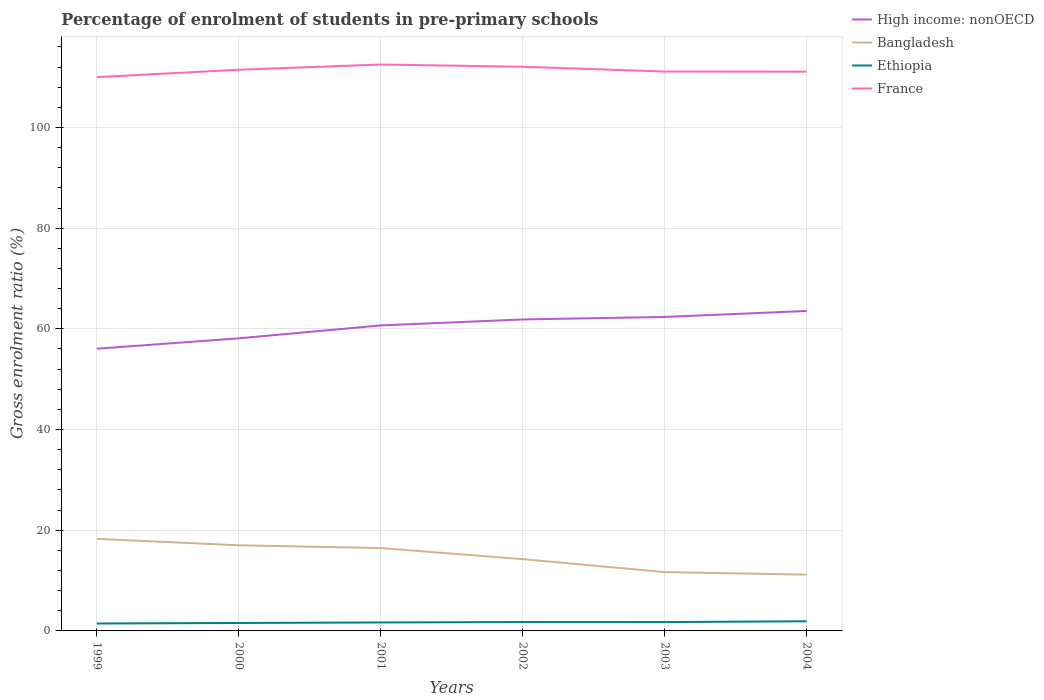Across all years, what is the maximum percentage of students enrolled in pre-primary schools in High income: nonOECD?
Ensure brevity in your answer.  56.05. In which year was the percentage of students enrolled in pre-primary schools in France maximum?
Provide a succinct answer. 1999. What is the total percentage of students enrolled in pre-primary schools in France in the graph?
Offer a very short reply. 0.36. What is the difference between the highest and the second highest percentage of students enrolled in pre-primary schools in High income: nonOECD?
Provide a short and direct response. 7.5. How many lines are there?
Your response must be concise. 4. How many years are there in the graph?
Your answer should be very brief. 6. Are the values on the major ticks of Y-axis written in scientific E-notation?
Your response must be concise. No. Does the graph contain any zero values?
Make the answer very short. No. Does the graph contain grids?
Make the answer very short. Yes. Where does the legend appear in the graph?
Offer a terse response. Top right. How many legend labels are there?
Offer a very short reply. 4. How are the legend labels stacked?
Offer a very short reply. Vertical. What is the title of the graph?
Offer a very short reply. Percentage of enrolment of students in pre-primary schools. What is the label or title of the X-axis?
Offer a terse response. Years. What is the Gross enrolment ratio (%) in High income: nonOECD in 1999?
Ensure brevity in your answer.  56.05. What is the Gross enrolment ratio (%) in Bangladesh in 1999?
Give a very brief answer. 18.29. What is the Gross enrolment ratio (%) of Ethiopia in 1999?
Your answer should be very brief. 1.47. What is the Gross enrolment ratio (%) in France in 1999?
Ensure brevity in your answer.  110. What is the Gross enrolment ratio (%) of High income: nonOECD in 2000?
Offer a terse response. 58.12. What is the Gross enrolment ratio (%) of Bangladesh in 2000?
Offer a very short reply. 17.01. What is the Gross enrolment ratio (%) in Ethiopia in 2000?
Give a very brief answer. 1.58. What is the Gross enrolment ratio (%) in France in 2000?
Your answer should be very brief. 111.47. What is the Gross enrolment ratio (%) in High income: nonOECD in 2001?
Ensure brevity in your answer.  60.68. What is the Gross enrolment ratio (%) in Bangladesh in 2001?
Make the answer very short. 16.46. What is the Gross enrolment ratio (%) of Ethiopia in 2001?
Give a very brief answer. 1.68. What is the Gross enrolment ratio (%) in France in 2001?
Offer a very short reply. 112.5. What is the Gross enrolment ratio (%) in High income: nonOECD in 2002?
Your answer should be very brief. 61.87. What is the Gross enrolment ratio (%) of Bangladesh in 2002?
Your answer should be compact. 14.25. What is the Gross enrolment ratio (%) in Ethiopia in 2002?
Ensure brevity in your answer.  1.76. What is the Gross enrolment ratio (%) in France in 2002?
Offer a terse response. 112.06. What is the Gross enrolment ratio (%) in High income: nonOECD in 2003?
Keep it short and to the point. 62.36. What is the Gross enrolment ratio (%) in Bangladesh in 2003?
Your answer should be compact. 11.68. What is the Gross enrolment ratio (%) in Ethiopia in 2003?
Provide a short and direct response. 1.76. What is the Gross enrolment ratio (%) of France in 2003?
Your response must be concise. 111.1. What is the Gross enrolment ratio (%) of High income: nonOECD in 2004?
Give a very brief answer. 63.55. What is the Gross enrolment ratio (%) in Bangladesh in 2004?
Provide a succinct answer. 11.18. What is the Gross enrolment ratio (%) in Ethiopia in 2004?
Your response must be concise. 1.92. What is the Gross enrolment ratio (%) of France in 2004?
Ensure brevity in your answer.  111.08. Across all years, what is the maximum Gross enrolment ratio (%) in High income: nonOECD?
Your answer should be compact. 63.55. Across all years, what is the maximum Gross enrolment ratio (%) of Bangladesh?
Provide a succinct answer. 18.29. Across all years, what is the maximum Gross enrolment ratio (%) of Ethiopia?
Offer a terse response. 1.92. Across all years, what is the maximum Gross enrolment ratio (%) in France?
Keep it short and to the point. 112.5. Across all years, what is the minimum Gross enrolment ratio (%) in High income: nonOECD?
Give a very brief answer. 56.05. Across all years, what is the minimum Gross enrolment ratio (%) of Bangladesh?
Give a very brief answer. 11.18. Across all years, what is the minimum Gross enrolment ratio (%) of Ethiopia?
Give a very brief answer. 1.47. Across all years, what is the minimum Gross enrolment ratio (%) in France?
Provide a short and direct response. 110. What is the total Gross enrolment ratio (%) in High income: nonOECD in the graph?
Provide a succinct answer. 362.62. What is the total Gross enrolment ratio (%) in Bangladesh in the graph?
Your response must be concise. 88.87. What is the total Gross enrolment ratio (%) in Ethiopia in the graph?
Your response must be concise. 10.17. What is the total Gross enrolment ratio (%) of France in the graph?
Your response must be concise. 668.2. What is the difference between the Gross enrolment ratio (%) in High income: nonOECD in 1999 and that in 2000?
Your answer should be compact. -2.07. What is the difference between the Gross enrolment ratio (%) in Bangladesh in 1999 and that in 2000?
Provide a short and direct response. 1.28. What is the difference between the Gross enrolment ratio (%) of Ethiopia in 1999 and that in 2000?
Provide a short and direct response. -0.1. What is the difference between the Gross enrolment ratio (%) in France in 1999 and that in 2000?
Make the answer very short. -1.47. What is the difference between the Gross enrolment ratio (%) in High income: nonOECD in 1999 and that in 2001?
Your response must be concise. -4.63. What is the difference between the Gross enrolment ratio (%) in Bangladesh in 1999 and that in 2001?
Your response must be concise. 1.83. What is the difference between the Gross enrolment ratio (%) of Ethiopia in 1999 and that in 2001?
Ensure brevity in your answer.  -0.21. What is the difference between the Gross enrolment ratio (%) in France in 1999 and that in 2001?
Your response must be concise. -2.5. What is the difference between the Gross enrolment ratio (%) of High income: nonOECD in 1999 and that in 2002?
Make the answer very short. -5.81. What is the difference between the Gross enrolment ratio (%) in Bangladesh in 1999 and that in 2002?
Ensure brevity in your answer.  4.03. What is the difference between the Gross enrolment ratio (%) of Ethiopia in 1999 and that in 2002?
Make the answer very short. -0.29. What is the difference between the Gross enrolment ratio (%) in France in 1999 and that in 2002?
Offer a terse response. -2.06. What is the difference between the Gross enrolment ratio (%) of High income: nonOECD in 1999 and that in 2003?
Ensure brevity in your answer.  -6.31. What is the difference between the Gross enrolment ratio (%) of Bangladesh in 1999 and that in 2003?
Make the answer very short. 6.6. What is the difference between the Gross enrolment ratio (%) of Ethiopia in 1999 and that in 2003?
Your response must be concise. -0.28. What is the difference between the Gross enrolment ratio (%) in France in 1999 and that in 2003?
Ensure brevity in your answer.  -1.11. What is the difference between the Gross enrolment ratio (%) in High income: nonOECD in 1999 and that in 2004?
Your response must be concise. -7.5. What is the difference between the Gross enrolment ratio (%) of Bangladesh in 1999 and that in 2004?
Give a very brief answer. 7.11. What is the difference between the Gross enrolment ratio (%) in Ethiopia in 1999 and that in 2004?
Give a very brief answer. -0.44. What is the difference between the Gross enrolment ratio (%) of France in 1999 and that in 2004?
Your answer should be compact. -1.08. What is the difference between the Gross enrolment ratio (%) in High income: nonOECD in 2000 and that in 2001?
Ensure brevity in your answer.  -2.56. What is the difference between the Gross enrolment ratio (%) in Bangladesh in 2000 and that in 2001?
Offer a very short reply. 0.55. What is the difference between the Gross enrolment ratio (%) in Ethiopia in 2000 and that in 2001?
Your answer should be very brief. -0.1. What is the difference between the Gross enrolment ratio (%) in France in 2000 and that in 2001?
Your answer should be compact. -1.03. What is the difference between the Gross enrolment ratio (%) in High income: nonOECD in 2000 and that in 2002?
Provide a succinct answer. -3.75. What is the difference between the Gross enrolment ratio (%) in Bangladesh in 2000 and that in 2002?
Your response must be concise. 2.75. What is the difference between the Gross enrolment ratio (%) of Ethiopia in 2000 and that in 2002?
Offer a very short reply. -0.19. What is the difference between the Gross enrolment ratio (%) in France in 2000 and that in 2002?
Ensure brevity in your answer.  -0.59. What is the difference between the Gross enrolment ratio (%) of High income: nonOECD in 2000 and that in 2003?
Ensure brevity in your answer.  -4.24. What is the difference between the Gross enrolment ratio (%) in Bangladesh in 2000 and that in 2003?
Provide a succinct answer. 5.32. What is the difference between the Gross enrolment ratio (%) in Ethiopia in 2000 and that in 2003?
Provide a succinct answer. -0.18. What is the difference between the Gross enrolment ratio (%) of France in 2000 and that in 2003?
Offer a very short reply. 0.36. What is the difference between the Gross enrolment ratio (%) in High income: nonOECD in 2000 and that in 2004?
Offer a very short reply. -5.43. What is the difference between the Gross enrolment ratio (%) in Bangladesh in 2000 and that in 2004?
Provide a short and direct response. 5.83. What is the difference between the Gross enrolment ratio (%) in Ethiopia in 2000 and that in 2004?
Provide a succinct answer. -0.34. What is the difference between the Gross enrolment ratio (%) of France in 2000 and that in 2004?
Your response must be concise. 0.39. What is the difference between the Gross enrolment ratio (%) in High income: nonOECD in 2001 and that in 2002?
Offer a very short reply. -1.19. What is the difference between the Gross enrolment ratio (%) in Bangladesh in 2001 and that in 2002?
Offer a terse response. 2.2. What is the difference between the Gross enrolment ratio (%) of Ethiopia in 2001 and that in 2002?
Give a very brief answer. -0.08. What is the difference between the Gross enrolment ratio (%) of France in 2001 and that in 2002?
Ensure brevity in your answer.  0.44. What is the difference between the Gross enrolment ratio (%) in High income: nonOECD in 2001 and that in 2003?
Your response must be concise. -1.68. What is the difference between the Gross enrolment ratio (%) in Bangladesh in 2001 and that in 2003?
Provide a succinct answer. 4.77. What is the difference between the Gross enrolment ratio (%) of Ethiopia in 2001 and that in 2003?
Offer a very short reply. -0.07. What is the difference between the Gross enrolment ratio (%) of France in 2001 and that in 2003?
Ensure brevity in your answer.  1.39. What is the difference between the Gross enrolment ratio (%) in High income: nonOECD in 2001 and that in 2004?
Give a very brief answer. -2.87. What is the difference between the Gross enrolment ratio (%) in Bangladesh in 2001 and that in 2004?
Provide a succinct answer. 5.28. What is the difference between the Gross enrolment ratio (%) in Ethiopia in 2001 and that in 2004?
Ensure brevity in your answer.  -0.23. What is the difference between the Gross enrolment ratio (%) in France in 2001 and that in 2004?
Your answer should be compact. 1.42. What is the difference between the Gross enrolment ratio (%) in High income: nonOECD in 2002 and that in 2003?
Keep it short and to the point. -0.49. What is the difference between the Gross enrolment ratio (%) of Bangladesh in 2002 and that in 2003?
Ensure brevity in your answer.  2.57. What is the difference between the Gross enrolment ratio (%) of Ethiopia in 2002 and that in 2003?
Your answer should be very brief. 0.01. What is the difference between the Gross enrolment ratio (%) in France in 2002 and that in 2003?
Give a very brief answer. 0.96. What is the difference between the Gross enrolment ratio (%) in High income: nonOECD in 2002 and that in 2004?
Provide a succinct answer. -1.68. What is the difference between the Gross enrolment ratio (%) of Bangladesh in 2002 and that in 2004?
Offer a terse response. 3.08. What is the difference between the Gross enrolment ratio (%) in Ethiopia in 2002 and that in 2004?
Your answer should be compact. -0.15. What is the difference between the Gross enrolment ratio (%) of High income: nonOECD in 2003 and that in 2004?
Your answer should be compact. -1.19. What is the difference between the Gross enrolment ratio (%) of Bangladesh in 2003 and that in 2004?
Provide a short and direct response. 0.51. What is the difference between the Gross enrolment ratio (%) in Ethiopia in 2003 and that in 2004?
Offer a terse response. -0.16. What is the difference between the Gross enrolment ratio (%) of France in 2003 and that in 2004?
Provide a succinct answer. 0.03. What is the difference between the Gross enrolment ratio (%) of High income: nonOECD in 1999 and the Gross enrolment ratio (%) of Bangladesh in 2000?
Your answer should be compact. 39.05. What is the difference between the Gross enrolment ratio (%) of High income: nonOECD in 1999 and the Gross enrolment ratio (%) of Ethiopia in 2000?
Give a very brief answer. 54.47. What is the difference between the Gross enrolment ratio (%) in High income: nonOECD in 1999 and the Gross enrolment ratio (%) in France in 2000?
Your answer should be compact. -55.41. What is the difference between the Gross enrolment ratio (%) of Bangladesh in 1999 and the Gross enrolment ratio (%) of Ethiopia in 2000?
Ensure brevity in your answer.  16.71. What is the difference between the Gross enrolment ratio (%) in Bangladesh in 1999 and the Gross enrolment ratio (%) in France in 2000?
Provide a short and direct response. -93.18. What is the difference between the Gross enrolment ratio (%) of Ethiopia in 1999 and the Gross enrolment ratio (%) of France in 2000?
Ensure brevity in your answer.  -109.99. What is the difference between the Gross enrolment ratio (%) of High income: nonOECD in 1999 and the Gross enrolment ratio (%) of Bangladesh in 2001?
Ensure brevity in your answer.  39.59. What is the difference between the Gross enrolment ratio (%) in High income: nonOECD in 1999 and the Gross enrolment ratio (%) in Ethiopia in 2001?
Provide a short and direct response. 54.37. What is the difference between the Gross enrolment ratio (%) of High income: nonOECD in 1999 and the Gross enrolment ratio (%) of France in 2001?
Ensure brevity in your answer.  -56.45. What is the difference between the Gross enrolment ratio (%) in Bangladesh in 1999 and the Gross enrolment ratio (%) in Ethiopia in 2001?
Keep it short and to the point. 16.61. What is the difference between the Gross enrolment ratio (%) of Bangladesh in 1999 and the Gross enrolment ratio (%) of France in 2001?
Keep it short and to the point. -94.21. What is the difference between the Gross enrolment ratio (%) in Ethiopia in 1999 and the Gross enrolment ratio (%) in France in 2001?
Ensure brevity in your answer.  -111.02. What is the difference between the Gross enrolment ratio (%) of High income: nonOECD in 1999 and the Gross enrolment ratio (%) of Bangladesh in 2002?
Give a very brief answer. 41.8. What is the difference between the Gross enrolment ratio (%) in High income: nonOECD in 1999 and the Gross enrolment ratio (%) in Ethiopia in 2002?
Your answer should be compact. 54.29. What is the difference between the Gross enrolment ratio (%) in High income: nonOECD in 1999 and the Gross enrolment ratio (%) in France in 2002?
Give a very brief answer. -56.01. What is the difference between the Gross enrolment ratio (%) in Bangladesh in 1999 and the Gross enrolment ratio (%) in Ethiopia in 2002?
Give a very brief answer. 16.53. What is the difference between the Gross enrolment ratio (%) of Bangladesh in 1999 and the Gross enrolment ratio (%) of France in 2002?
Give a very brief answer. -93.77. What is the difference between the Gross enrolment ratio (%) of Ethiopia in 1999 and the Gross enrolment ratio (%) of France in 2002?
Provide a short and direct response. -110.59. What is the difference between the Gross enrolment ratio (%) in High income: nonOECD in 1999 and the Gross enrolment ratio (%) in Bangladesh in 2003?
Give a very brief answer. 44.37. What is the difference between the Gross enrolment ratio (%) in High income: nonOECD in 1999 and the Gross enrolment ratio (%) in Ethiopia in 2003?
Keep it short and to the point. 54.29. What is the difference between the Gross enrolment ratio (%) in High income: nonOECD in 1999 and the Gross enrolment ratio (%) in France in 2003?
Make the answer very short. -55.05. What is the difference between the Gross enrolment ratio (%) of Bangladesh in 1999 and the Gross enrolment ratio (%) of Ethiopia in 2003?
Your answer should be compact. 16.53. What is the difference between the Gross enrolment ratio (%) of Bangladesh in 1999 and the Gross enrolment ratio (%) of France in 2003?
Your answer should be very brief. -92.81. What is the difference between the Gross enrolment ratio (%) in Ethiopia in 1999 and the Gross enrolment ratio (%) in France in 2003?
Your answer should be compact. -109.63. What is the difference between the Gross enrolment ratio (%) of High income: nonOECD in 1999 and the Gross enrolment ratio (%) of Bangladesh in 2004?
Ensure brevity in your answer.  44.87. What is the difference between the Gross enrolment ratio (%) in High income: nonOECD in 1999 and the Gross enrolment ratio (%) in Ethiopia in 2004?
Keep it short and to the point. 54.13. What is the difference between the Gross enrolment ratio (%) in High income: nonOECD in 1999 and the Gross enrolment ratio (%) in France in 2004?
Offer a terse response. -55.02. What is the difference between the Gross enrolment ratio (%) of Bangladesh in 1999 and the Gross enrolment ratio (%) of Ethiopia in 2004?
Ensure brevity in your answer.  16.37. What is the difference between the Gross enrolment ratio (%) of Bangladesh in 1999 and the Gross enrolment ratio (%) of France in 2004?
Make the answer very short. -92.79. What is the difference between the Gross enrolment ratio (%) of Ethiopia in 1999 and the Gross enrolment ratio (%) of France in 2004?
Offer a very short reply. -109.6. What is the difference between the Gross enrolment ratio (%) in High income: nonOECD in 2000 and the Gross enrolment ratio (%) in Bangladesh in 2001?
Keep it short and to the point. 41.66. What is the difference between the Gross enrolment ratio (%) of High income: nonOECD in 2000 and the Gross enrolment ratio (%) of Ethiopia in 2001?
Provide a succinct answer. 56.43. What is the difference between the Gross enrolment ratio (%) of High income: nonOECD in 2000 and the Gross enrolment ratio (%) of France in 2001?
Offer a terse response. -54.38. What is the difference between the Gross enrolment ratio (%) in Bangladesh in 2000 and the Gross enrolment ratio (%) in Ethiopia in 2001?
Your answer should be compact. 15.32. What is the difference between the Gross enrolment ratio (%) in Bangladesh in 2000 and the Gross enrolment ratio (%) in France in 2001?
Offer a terse response. -95.49. What is the difference between the Gross enrolment ratio (%) in Ethiopia in 2000 and the Gross enrolment ratio (%) in France in 2001?
Make the answer very short. -110.92. What is the difference between the Gross enrolment ratio (%) in High income: nonOECD in 2000 and the Gross enrolment ratio (%) in Bangladesh in 2002?
Ensure brevity in your answer.  43.86. What is the difference between the Gross enrolment ratio (%) of High income: nonOECD in 2000 and the Gross enrolment ratio (%) of Ethiopia in 2002?
Your response must be concise. 56.35. What is the difference between the Gross enrolment ratio (%) of High income: nonOECD in 2000 and the Gross enrolment ratio (%) of France in 2002?
Give a very brief answer. -53.94. What is the difference between the Gross enrolment ratio (%) of Bangladesh in 2000 and the Gross enrolment ratio (%) of Ethiopia in 2002?
Your answer should be very brief. 15.24. What is the difference between the Gross enrolment ratio (%) in Bangladesh in 2000 and the Gross enrolment ratio (%) in France in 2002?
Your answer should be very brief. -95.05. What is the difference between the Gross enrolment ratio (%) of Ethiopia in 2000 and the Gross enrolment ratio (%) of France in 2002?
Your response must be concise. -110.48. What is the difference between the Gross enrolment ratio (%) in High income: nonOECD in 2000 and the Gross enrolment ratio (%) in Bangladesh in 2003?
Offer a very short reply. 46.43. What is the difference between the Gross enrolment ratio (%) of High income: nonOECD in 2000 and the Gross enrolment ratio (%) of Ethiopia in 2003?
Give a very brief answer. 56.36. What is the difference between the Gross enrolment ratio (%) in High income: nonOECD in 2000 and the Gross enrolment ratio (%) in France in 2003?
Offer a very short reply. -52.99. What is the difference between the Gross enrolment ratio (%) in Bangladesh in 2000 and the Gross enrolment ratio (%) in Ethiopia in 2003?
Provide a succinct answer. 15.25. What is the difference between the Gross enrolment ratio (%) in Bangladesh in 2000 and the Gross enrolment ratio (%) in France in 2003?
Give a very brief answer. -94.1. What is the difference between the Gross enrolment ratio (%) in Ethiopia in 2000 and the Gross enrolment ratio (%) in France in 2003?
Your response must be concise. -109.53. What is the difference between the Gross enrolment ratio (%) in High income: nonOECD in 2000 and the Gross enrolment ratio (%) in Bangladesh in 2004?
Your answer should be compact. 46.94. What is the difference between the Gross enrolment ratio (%) in High income: nonOECD in 2000 and the Gross enrolment ratio (%) in Ethiopia in 2004?
Ensure brevity in your answer.  56.2. What is the difference between the Gross enrolment ratio (%) in High income: nonOECD in 2000 and the Gross enrolment ratio (%) in France in 2004?
Offer a very short reply. -52.96. What is the difference between the Gross enrolment ratio (%) in Bangladesh in 2000 and the Gross enrolment ratio (%) in Ethiopia in 2004?
Your response must be concise. 15.09. What is the difference between the Gross enrolment ratio (%) of Bangladesh in 2000 and the Gross enrolment ratio (%) of France in 2004?
Keep it short and to the point. -94.07. What is the difference between the Gross enrolment ratio (%) of Ethiopia in 2000 and the Gross enrolment ratio (%) of France in 2004?
Give a very brief answer. -109.5. What is the difference between the Gross enrolment ratio (%) of High income: nonOECD in 2001 and the Gross enrolment ratio (%) of Bangladesh in 2002?
Your answer should be very brief. 46.42. What is the difference between the Gross enrolment ratio (%) in High income: nonOECD in 2001 and the Gross enrolment ratio (%) in Ethiopia in 2002?
Your answer should be compact. 58.92. What is the difference between the Gross enrolment ratio (%) in High income: nonOECD in 2001 and the Gross enrolment ratio (%) in France in 2002?
Offer a very short reply. -51.38. What is the difference between the Gross enrolment ratio (%) of Bangladesh in 2001 and the Gross enrolment ratio (%) of Ethiopia in 2002?
Offer a very short reply. 14.69. What is the difference between the Gross enrolment ratio (%) of Bangladesh in 2001 and the Gross enrolment ratio (%) of France in 2002?
Make the answer very short. -95.6. What is the difference between the Gross enrolment ratio (%) of Ethiopia in 2001 and the Gross enrolment ratio (%) of France in 2002?
Give a very brief answer. -110.38. What is the difference between the Gross enrolment ratio (%) of High income: nonOECD in 2001 and the Gross enrolment ratio (%) of Bangladesh in 2003?
Provide a short and direct response. 48.99. What is the difference between the Gross enrolment ratio (%) in High income: nonOECD in 2001 and the Gross enrolment ratio (%) in Ethiopia in 2003?
Give a very brief answer. 58.92. What is the difference between the Gross enrolment ratio (%) of High income: nonOECD in 2001 and the Gross enrolment ratio (%) of France in 2003?
Your answer should be compact. -50.42. What is the difference between the Gross enrolment ratio (%) in Bangladesh in 2001 and the Gross enrolment ratio (%) in Ethiopia in 2003?
Your response must be concise. 14.7. What is the difference between the Gross enrolment ratio (%) of Bangladesh in 2001 and the Gross enrolment ratio (%) of France in 2003?
Provide a succinct answer. -94.65. What is the difference between the Gross enrolment ratio (%) of Ethiopia in 2001 and the Gross enrolment ratio (%) of France in 2003?
Make the answer very short. -109.42. What is the difference between the Gross enrolment ratio (%) of High income: nonOECD in 2001 and the Gross enrolment ratio (%) of Bangladesh in 2004?
Offer a very short reply. 49.5. What is the difference between the Gross enrolment ratio (%) of High income: nonOECD in 2001 and the Gross enrolment ratio (%) of Ethiopia in 2004?
Offer a terse response. 58.76. What is the difference between the Gross enrolment ratio (%) of High income: nonOECD in 2001 and the Gross enrolment ratio (%) of France in 2004?
Provide a short and direct response. -50.4. What is the difference between the Gross enrolment ratio (%) of Bangladesh in 2001 and the Gross enrolment ratio (%) of Ethiopia in 2004?
Provide a succinct answer. 14.54. What is the difference between the Gross enrolment ratio (%) in Bangladesh in 2001 and the Gross enrolment ratio (%) in France in 2004?
Offer a terse response. -94.62. What is the difference between the Gross enrolment ratio (%) in Ethiopia in 2001 and the Gross enrolment ratio (%) in France in 2004?
Ensure brevity in your answer.  -109.39. What is the difference between the Gross enrolment ratio (%) in High income: nonOECD in 2002 and the Gross enrolment ratio (%) in Bangladesh in 2003?
Provide a succinct answer. 50.18. What is the difference between the Gross enrolment ratio (%) of High income: nonOECD in 2002 and the Gross enrolment ratio (%) of Ethiopia in 2003?
Give a very brief answer. 60.11. What is the difference between the Gross enrolment ratio (%) of High income: nonOECD in 2002 and the Gross enrolment ratio (%) of France in 2003?
Keep it short and to the point. -49.24. What is the difference between the Gross enrolment ratio (%) in Bangladesh in 2002 and the Gross enrolment ratio (%) in Ethiopia in 2003?
Make the answer very short. 12.5. What is the difference between the Gross enrolment ratio (%) of Bangladesh in 2002 and the Gross enrolment ratio (%) of France in 2003?
Keep it short and to the point. -96.85. What is the difference between the Gross enrolment ratio (%) in Ethiopia in 2002 and the Gross enrolment ratio (%) in France in 2003?
Offer a terse response. -109.34. What is the difference between the Gross enrolment ratio (%) in High income: nonOECD in 2002 and the Gross enrolment ratio (%) in Bangladesh in 2004?
Provide a short and direct response. 50.69. What is the difference between the Gross enrolment ratio (%) in High income: nonOECD in 2002 and the Gross enrolment ratio (%) in Ethiopia in 2004?
Keep it short and to the point. 59.95. What is the difference between the Gross enrolment ratio (%) of High income: nonOECD in 2002 and the Gross enrolment ratio (%) of France in 2004?
Keep it short and to the point. -49.21. What is the difference between the Gross enrolment ratio (%) in Bangladesh in 2002 and the Gross enrolment ratio (%) in Ethiopia in 2004?
Offer a terse response. 12.34. What is the difference between the Gross enrolment ratio (%) of Bangladesh in 2002 and the Gross enrolment ratio (%) of France in 2004?
Provide a succinct answer. -96.82. What is the difference between the Gross enrolment ratio (%) of Ethiopia in 2002 and the Gross enrolment ratio (%) of France in 2004?
Offer a terse response. -109.31. What is the difference between the Gross enrolment ratio (%) in High income: nonOECD in 2003 and the Gross enrolment ratio (%) in Bangladesh in 2004?
Make the answer very short. 51.18. What is the difference between the Gross enrolment ratio (%) of High income: nonOECD in 2003 and the Gross enrolment ratio (%) of Ethiopia in 2004?
Provide a succinct answer. 60.44. What is the difference between the Gross enrolment ratio (%) of High income: nonOECD in 2003 and the Gross enrolment ratio (%) of France in 2004?
Provide a short and direct response. -48.72. What is the difference between the Gross enrolment ratio (%) in Bangladesh in 2003 and the Gross enrolment ratio (%) in Ethiopia in 2004?
Provide a short and direct response. 9.77. What is the difference between the Gross enrolment ratio (%) of Bangladesh in 2003 and the Gross enrolment ratio (%) of France in 2004?
Keep it short and to the point. -99.39. What is the difference between the Gross enrolment ratio (%) in Ethiopia in 2003 and the Gross enrolment ratio (%) in France in 2004?
Offer a terse response. -109.32. What is the average Gross enrolment ratio (%) of High income: nonOECD per year?
Keep it short and to the point. 60.44. What is the average Gross enrolment ratio (%) of Bangladesh per year?
Your response must be concise. 14.81. What is the average Gross enrolment ratio (%) in Ethiopia per year?
Offer a very short reply. 1.7. What is the average Gross enrolment ratio (%) in France per year?
Give a very brief answer. 111.37. In the year 1999, what is the difference between the Gross enrolment ratio (%) in High income: nonOECD and Gross enrolment ratio (%) in Bangladesh?
Your answer should be very brief. 37.76. In the year 1999, what is the difference between the Gross enrolment ratio (%) of High income: nonOECD and Gross enrolment ratio (%) of Ethiopia?
Offer a terse response. 54.58. In the year 1999, what is the difference between the Gross enrolment ratio (%) in High income: nonOECD and Gross enrolment ratio (%) in France?
Offer a terse response. -53.95. In the year 1999, what is the difference between the Gross enrolment ratio (%) of Bangladesh and Gross enrolment ratio (%) of Ethiopia?
Provide a succinct answer. 16.82. In the year 1999, what is the difference between the Gross enrolment ratio (%) of Bangladesh and Gross enrolment ratio (%) of France?
Your answer should be compact. -91.71. In the year 1999, what is the difference between the Gross enrolment ratio (%) in Ethiopia and Gross enrolment ratio (%) in France?
Provide a short and direct response. -108.52. In the year 2000, what is the difference between the Gross enrolment ratio (%) of High income: nonOECD and Gross enrolment ratio (%) of Bangladesh?
Your response must be concise. 41.11. In the year 2000, what is the difference between the Gross enrolment ratio (%) in High income: nonOECD and Gross enrolment ratio (%) in Ethiopia?
Your response must be concise. 56.54. In the year 2000, what is the difference between the Gross enrolment ratio (%) in High income: nonOECD and Gross enrolment ratio (%) in France?
Your answer should be compact. -53.35. In the year 2000, what is the difference between the Gross enrolment ratio (%) of Bangladesh and Gross enrolment ratio (%) of Ethiopia?
Your answer should be very brief. 15.43. In the year 2000, what is the difference between the Gross enrolment ratio (%) in Bangladesh and Gross enrolment ratio (%) in France?
Offer a terse response. -94.46. In the year 2000, what is the difference between the Gross enrolment ratio (%) in Ethiopia and Gross enrolment ratio (%) in France?
Provide a short and direct response. -109.89. In the year 2001, what is the difference between the Gross enrolment ratio (%) in High income: nonOECD and Gross enrolment ratio (%) in Bangladesh?
Offer a terse response. 44.22. In the year 2001, what is the difference between the Gross enrolment ratio (%) of High income: nonOECD and Gross enrolment ratio (%) of Ethiopia?
Provide a succinct answer. 59. In the year 2001, what is the difference between the Gross enrolment ratio (%) of High income: nonOECD and Gross enrolment ratio (%) of France?
Offer a terse response. -51.82. In the year 2001, what is the difference between the Gross enrolment ratio (%) of Bangladesh and Gross enrolment ratio (%) of Ethiopia?
Your response must be concise. 14.78. In the year 2001, what is the difference between the Gross enrolment ratio (%) of Bangladesh and Gross enrolment ratio (%) of France?
Keep it short and to the point. -96.04. In the year 2001, what is the difference between the Gross enrolment ratio (%) of Ethiopia and Gross enrolment ratio (%) of France?
Give a very brief answer. -110.82. In the year 2002, what is the difference between the Gross enrolment ratio (%) in High income: nonOECD and Gross enrolment ratio (%) in Bangladesh?
Make the answer very short. 47.61. In the year 2002, what is the difference between the Gross enrolment ratio (%) of High income: nonOECD and Gross enrolment ratio (%) of Ethiopia?
Your response must be concise. 60.1. In the year 2002, what is the difference between the Gross enrolment ratio (%) in High income: nonOECD and Gross enrolment ratio (%) in France?
Your response must be concise. -50.19. In the year 2002, what is the difference between the Gross enrolment ratio (%) in Bangladesh and Gross enrolment ratio (%) in Ethiopia?
Provide a succinct answer. 12.49. In the year 2002, what is the difference between the Gross enrolment ratio (%) in Bangladesh and Gross enrolment ratio (%) in France?
Provide a succinct answer. -97.81. In the year 2002, what is the difference between the Gross enrolment ratio (%) in Ethiopia and Gross enrolment ratio (%) in France?
Give a very brief answer. -110.3. In the year 2003, what is the difference between the Gross enrolment ratio (%) of High income: nonOECD and Gross enrolment ratio (%) of Bangladesh?
Provide a short and direct response. 50.67. In the year 2003, what is the difference between the Gross enrolment ratio (%) of High income: nonOECD and Gross enrolment ratio (%) of Ethiopia?
Ensure brevity in your answer.  60.6. In the year 2003, what is the difference between the Gross enrolment ratio (%) of High income: nonOECD and Gross enrolment ratio (%) of France?
Make the answer very short. -48.74. In the year 2003, what is the difference between the Gross enrolment ratio (%) of Bangladesh and Gross enrolment ratio (%) of Ethiopia?
Offer a terse response. 9.93. In the year 2003, what is the difference between the Gross enrolment ratio (%) in Bangladesh and Gross enrolment ratio (%) in France?
Provide a short and direct response. -99.42. In the year 2003, what is the difference between the Gross enrolment ratio (%) of Ethiopia and Gross enrolment ratio (%) of France?
Give a very brief answer. -109.35. In the year 2004, what is the difference between the Gross enrolment ratio (%) of High income: nonOECD and Gross enrolment ratio (%) of Bangladesh?
Offer a very short reply. 52.37. In the year 2004, what is the difference between the Gross enrolment ratio (%) in High income: nonOECD and Gross enrolment ratio (%) in Ethiopia?
Offer a very short reply. 61.63. In the year 2004, what is the difference between the Gross enrolment ratio (%) in High income: nonOECD and Gross enrolment ratio (%) in France?
Offer a terse response. -47.53. In the year 2004, what is the difference between the Gross enrolment ratio (%) of Bangladesh and Gross enrolment ratio (%) of Ethiopia?
Provide a succinct answer. 9.26. In the year 2004, what is the difference between the Gross enrolment ratio (%) in Bangladesh and Gross enrolment ratio (%) in France?
Give a very brief answer. -99.9. In the year 2004, what is the difference between the Gross enrolment ratio (%) of Ethiopia and Gross enrolment ratio (%) of France?
Offer a terse response. -109.16. What is the ratio of the Gross enrolment ratio (%) of High income: nonOECD in 1999 to that in 2000?
Provide a succinct answer. 0.96. What is the ratio of the Gross enrolment ratio (%) in Bangladesh in 1999 to that in 2000?
Keep it short and to the point. 1.08. What is the ratio of the Gross enrolment ratio (%) in Ethiopia in 1999 to that in 2000?
Keep it short and to the point. 0.93. What is the ratio of the Gross enrolment ratio (%) in High income: nonOECD in 1999 to that in 2001?
Keep it short and to the point. 0.92. What is the ratio of the Gross enrolment ratio (%) in Bangladesh in 1999 to that in 2001?
Give a very brief answer. 1.11. What is the ratio of the Gross enrolment ratio (%) of Ethiopia in 1999 to that in 2001?
Offer a terse response. 0.88. What is the ratio of the Gross enrolment ratio (%) of France in 1999 to that in 2001?
Provide a succinct answer. 0.98. What is the ratio of the Gross enrolment ratio (%) in High income: nonOECD in 1999 to that in 2002?
Your answer should be compact. 0.91. What is the ratio of the Gross enrolment ratio (%) of Bangladesh in 1999 to that in 2002?
Provide a succinct answer. 1.28. What is the ratio of the Gross enrolment ratio (%) in Ethiopia in 1999 to that in 2002?
Make the answer very short. 0.84. What is the ratio of the Gross enrolment ratio (%) in France in 1999 to that in 2002?
Give a very brief answer. 0.98. What is the ratio of the Gross enrolment ratio (%) of High income: nonOECD in 1999 to that in 2003?
Provide a succinct answer. 0.9. What is the ratio of the Gross enrolment ratio (%) of Bangladesh in 1999 to that in 2003?
Offer a very short reply. 1.57. What is the ratio of the Gross enrolment ratio (%) in Ethiopia in 1999 to that in 2003?
Offer a very short reply. 0.84. What is the ratio of the Gross enrolment ratio (%) of France in 1999 to that in 2003?
Offer a very short reply. 0.99. What is the ratio of the Gross enrolment ratio (%) in High income: nonOECD in 1999 to that in 2004?
Offer a very short reply. 0.88. What is the ratio of the Gross enrolment ratio (%) in Bangladesh in 1999 to that in 2004?
Your answer should be very brief. 1.64. What is the ratio of the Gross enrolment ratio (%) of Ethiopia in 1999 to that in 2004?
Make the answer very short. 0.77. What is the ratio of the Gross enrolment ratio (%) of France in 1999 to that in 2004?
Give a very brief answer. 0.99. What is the ratio of the Gross enrolment ratio (%) in High income: nonOECD in 2000 to that in 2001?
Keep it short and to the point. 0.96. What is the ratio of the Gross enrolment ratio (%) in Ethiopia in 2000 to that in 2001?
Keep it short and to the point. 0.94. What is the ratio of the Gross enrolment ratio (%) of France in 2000 to that in 2001?
Ensure brevity in your answer.  0.99. What is the ratio of the Gross enrolment ratio (%) in High income: nonOECD in 2000 to that in 2002?
Ensure brevity in your answer.  0.94. What is the ratio of the Gross enrolment ratio (%) in Bangladesh in 2000 to that in 2002?
Make the answer very short. 1.19. What is the ratio of the Gross enrolment ratio (%) of Ethiopia in 2000 to that in 2002?
Offer a terse response. 0.89. What is the ratio of the Gross enrolment ratio (%) of High income: nonOECD in 2000 to that in 2003?
Make the answer very short. 0.93. What is the ratio of the Gross enrolment ratio (%) of Bangladesh in 2000 to that in 2003?
Your answer should be compact. 1.46. What is the ratio of the Gross enrolment ratio (%) of Ethiopia in 2000 to that in 2003?
Keep it short and to the point. 0.9. What is the ratio of the Gross enrolment ratio (%) of France in 2000 to that in 2003?
Offer a terse response. 1. What is the ratio of the Gross enrolment ratio (%) of High income: nonOECD in 2000 to that in 2004?
Your answer should be very brief. 0.91. What is the ratio of the Gross enrolment ratio (%) in Bangladesh in 2000 to that in 2004?
Ensure brevity in your answer.  1.52. What is the ratio of the Gross enrolment ratio (%) of Ethiopia in 2000 to that in 2004?
Your answer should be compact. 0.82. What is the ratio of the Gross enrolment ratio (%) in France in 2000 to that in 2004?
Your response must be concise. 1. What is the ratio of the Gross enrolment ratio (%) of High income: nonOECD in 2001 to that in 2002?
Ensure brevity in your answer.  0.98. What is the ratio of the Gross enrolment ratio (%) in Bangladesh in 2001 to that in 2002?
Keep it short and to the point. 1.15. What is the ratio of the Gross enrolment ratio (%) in Ethiopia in 2001 to that in 2002?
Your answer should be very brief. 0.95. What is the ratio of the Gross enrolment ratio (%) in France in 2001 to that in 2002?
Offer a terse response. 1. What is the ratio of the Gross enrolment ratio (%) of High income: nonOECD in 2001 to that in 2003?
Ensure brevity in your answer.  0.97. What is the ratio of the Gross enrolment ratio (%) in Bangladesh in 2001 to that in 2003?
Your answer should be compact. 1.41. What is the ratio of the Gross enrolment ratio (%) of Ethiopia in 2001 to that in 2003?
Provide a short and direct response. 0.96. What is the ratio of the Gross enrolment ratio (%) of France in 2001 to that in 2003?
Make the answer very short. 1.01. What is the ratio of the Gross enrolment ratio (%) of High income: nonOECD in 2001 to that in 2004?
Make the answer very short. 0.95. What is the ratio of the Gross enrolment ratio (%) of Bangladesh in 2001 to that in 2004?
Offer a very short reply. 1.47. What is the ratio of the Gross enrolment ratio (%) in Ethiopia in 2001 to that in 2004?
Give a very brief answer. 0.88. What is the ratio of the Gross enrolment ratio (%) of France in 2001 to that in 2004?
Your answer should be very brief. 1.01. What is the ratio of the Gross enrolment ratio (%) of Bangladesh in 2002 to that in 2003?
Make the answer very short. 1.22. What is the ratio of the Gross enrolment ratio (%) in Ethiopia in 2002 to that in 2003?
Give a very brief answer. 1. What is the ratio of the Gross enrolment ratio (%) of France in 2002 to that in 2003?
Provide a short and direct response. 1.01. What is the ratio of the Gross enrolment ratio (%) in High income: nonOECD in 2002 to that in 2004?
Your answer should be very brief. 0.97. What is the ratio of the Gross enrolment ratio (%) in Bangladesh in 2002 to that in 2004?
Your response must be concise. 1.28. What is the ratio of the Gross enrolment ratio (%) in Ethiopia in 2002 to that in 2004?
Keep it short and to the point. 0.92. What is the ratio of the Gross enrolment ratio (%) of France in 2002 to that in 2004?
Provide a succinct answer. 1.01. What is the ratio of the Gross enrolment ratio (%) of High income: nonOECD in 2003 to that in 2004?
Offer a very short reply. 0.98. What is the ratio of the Gross enrolment ratio (%) of Bangladesh in 2003 to that in 2004?
Offer a very short reply. 1.05. What is the ratio of the Gross enrolment ratio (%) of Ethiopia in 2003 to that in 2004?
Provide a short and direct response. 0.92. What is the ratio of the Gross enrolment ratio (%) in France in 2003 to that in 2004?
Provide a succinct answer. 1. What is the difference between the highest and the second highest Gross enrolment ratio (%) in High income: nonOECD?
Offer a very short reply. 1.19. What is the difference between the highest and the second highest Gross enrolment ratio (%) of Bangladesh?
Make the answer very short. 1.28. What is the difference between the highest and the second highest Gross enrolment ratio (%) in Ethiopia?
Make the answer very short. 0.15. What is the difference between the highest and the second highest Gross enrolment ratio (%) in France?
Offer a very short reply. 0.44. What is the difference between the highest and the lowest Gross enrolment ratio (%) of High income: nonOECD?
Your answer should be very brief. 7.5. What is the difference between the highest and the lowest Gross enrolment ratio (%) of Bangladesh?
Your answer should be very brief. 7.11. What is the difference between the highest and the lowest Gross enrolment ratio (%) in Ethiopia?
Your answer should be very brief. 0.44. What is the difference between the highest and the lowest Gross enrolment ratio (%) in France?
Provide a succinct answer. 2.5. 